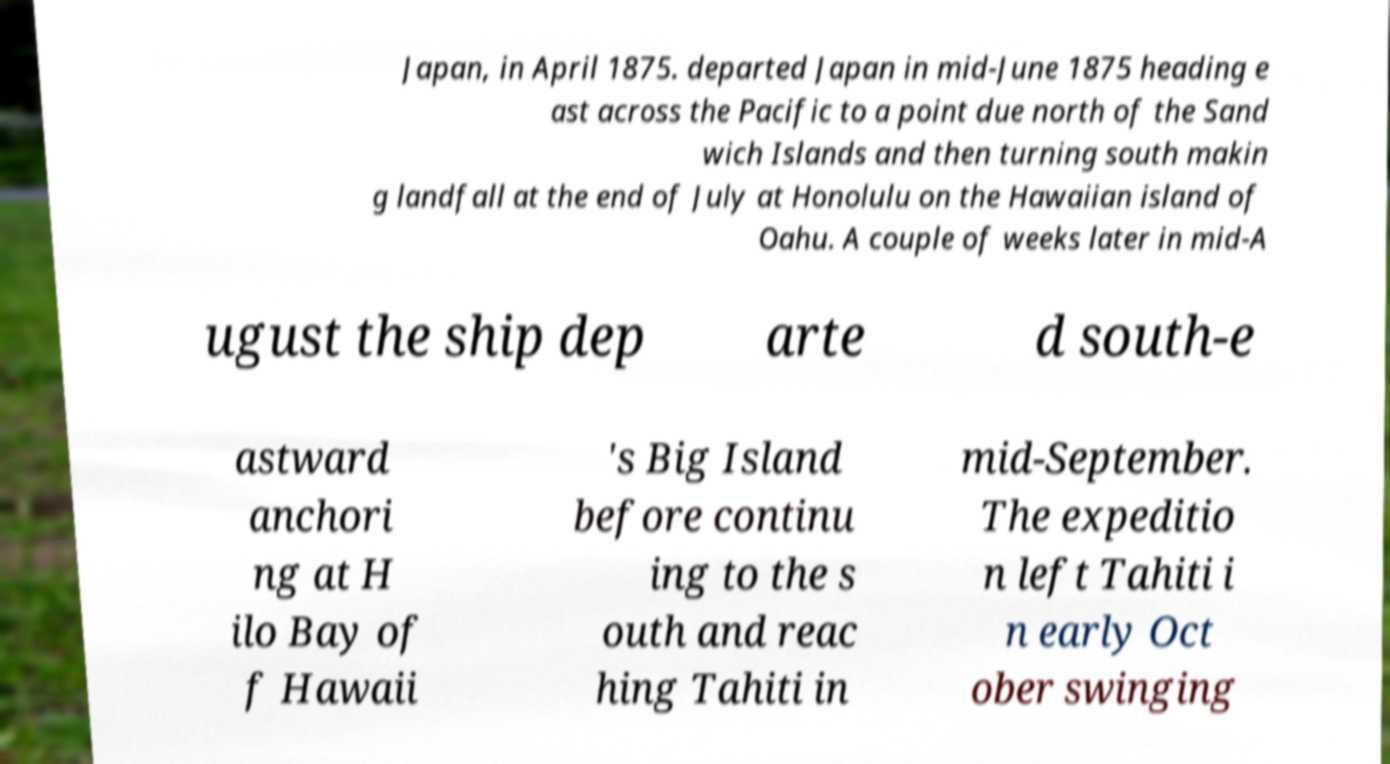What messages or text are displayed in this image? I need them in a readable, typed format. Japan, in April 1875. departed Japan in mid-June 1875 heading e ast across the Pacific to a point due north of the Sand wich Islands and then turning south makin g landfall at the end of July at Honolulu on the Hawaiian island of Oahu. A couple of weeks later in mid-A ugust the ship dep arte d south-e astward anchori ng at H ilo Bay of f Hawaii 's Big Island before continu ing to the s outh and reac hing Tahiti in mid-September. The expeditio n left Tahiti i n early Oct ober swinging 